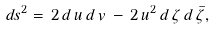Convert formula to latex. <formula><loc_0><loc_0><loc_500><loc_500>d s ^ { 2 } = \, 2 \, d \, u \, d \, v \, - \, 2 \, u ^ { 2 } \, d \, \zeta \, d \, \bar { \zeta } ,</formula> 